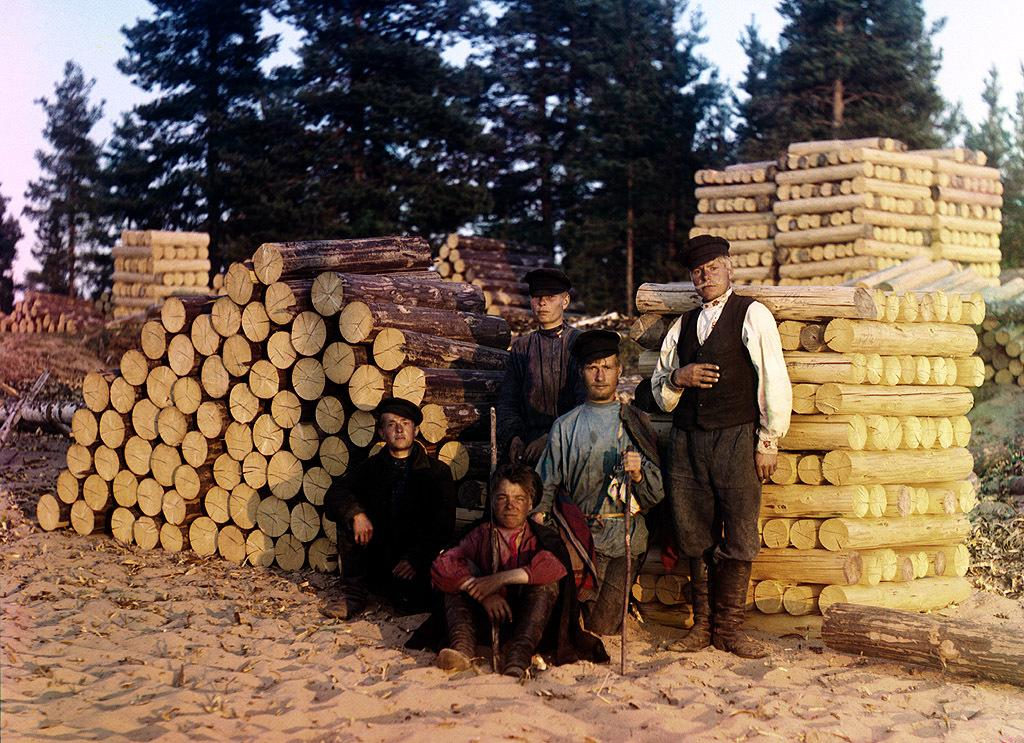How many people are in the image? There are people in the image, but the exact number is not specified. What are some people wearing in the image? Some people are wearing caps in the image. What object can be seen in the image that is long and thin? There is a stick in the image. How many people are standing in the image? Two people are standing in the image. What type of surface is visible in the image? There is sand in the image. What type of structures can be seen in the image? There are wooden poles in the image. What type of vegetation is visible in the image? There are trees in the image. What part of the natural environment is visible in the image? The sky is visible in the image. What grade is the sand in the image? The sand in the image is not assigned a grade, as sand is a natural substance and not a graded material. 